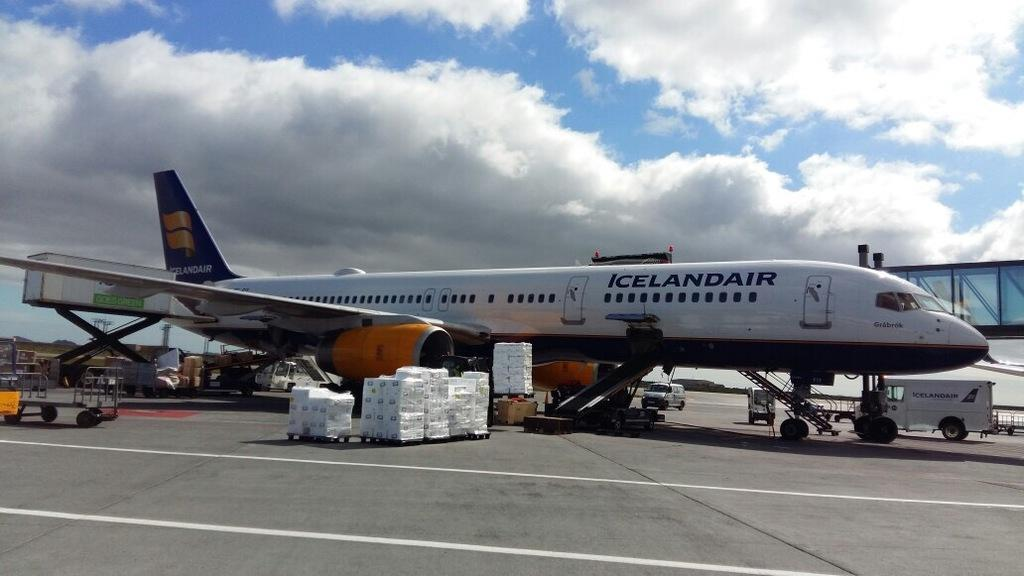<image>
Write a terse but informative summary of the picture. A blue and white airplane with the words Iceland Air written on the side\ 